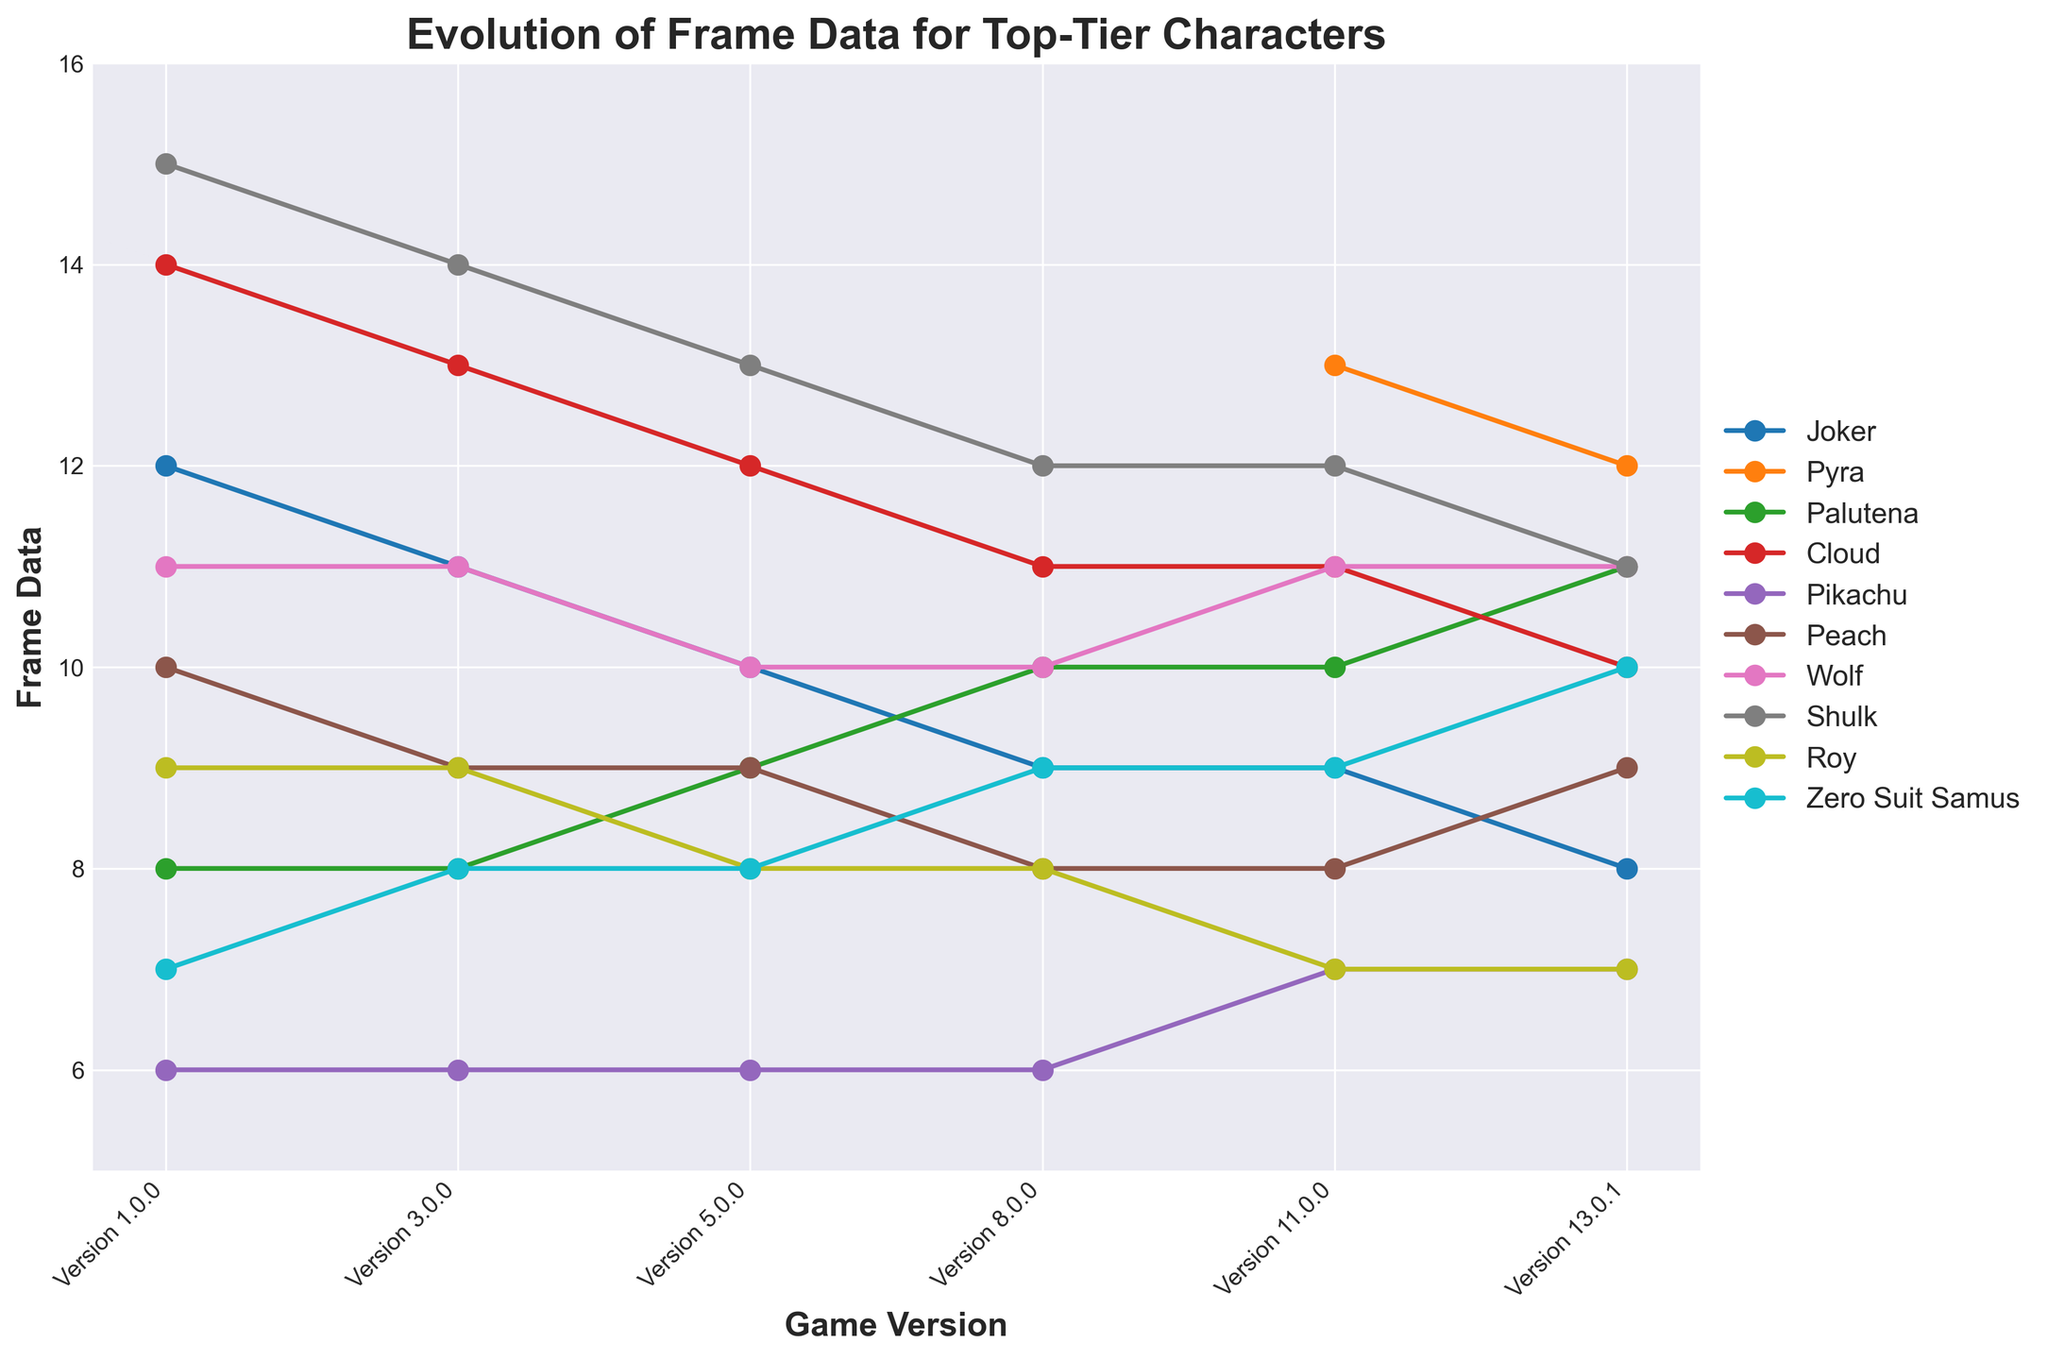What is the frame data of Joker in version 13.0.1? Look at the line corresponding to Joker and find the y-axis value at the x-axis point labeled "Version 13.0.1"
Answer: 8 Which character showed the most improvement in frame data between version 1.0.0 and version 13.0.1? Compare the frame data for each character at version 1.0.0 and version 13.0.1, and determine which character has the largest decrease in frame data
Answer: Joker Which version did Palutena's frame data first reach double digits? Trace the line corresponding to Palutena and find the earliest x-axis point where the y-axis value is 10 or more
Answer: Version 8.0.0 Did Pikachu's frame data ever change, and if so, in which versions? Observe the line corresponding to Pikachu and identify any points where the frame data changes
Answer: Yes, versions 11.0.0 and 13.0.1 What is the average frame data of Cloud from version 1.0.0 to version 13.0.1? Sum the frame data values of Cloud from all versions and divide by the number of versions (5)
Answer: Average frame data is (14 + 13 + 12 + 11 + 11 + 10) / 6 = 11.83 Which two characters have identical frame data in version 13.0.1? Observe the y-axis values for each character at version 13.0.1 and find any matches
Answer: Wolf and Palutena How many characters had an improvement in frame data by version 13.0.1 compared to their initial version? Count the number of characters whose frame data has decreased from version 1.0.0 to version 13.0.1
Answer: Seven characters Which characters have more frame data in version 13.0.1 than they had in version 11.0.0? Compare the frame data values of all characters between versions 13.0.1 and 11.0.0
Answer: Palutena and Zero Suit Samus 